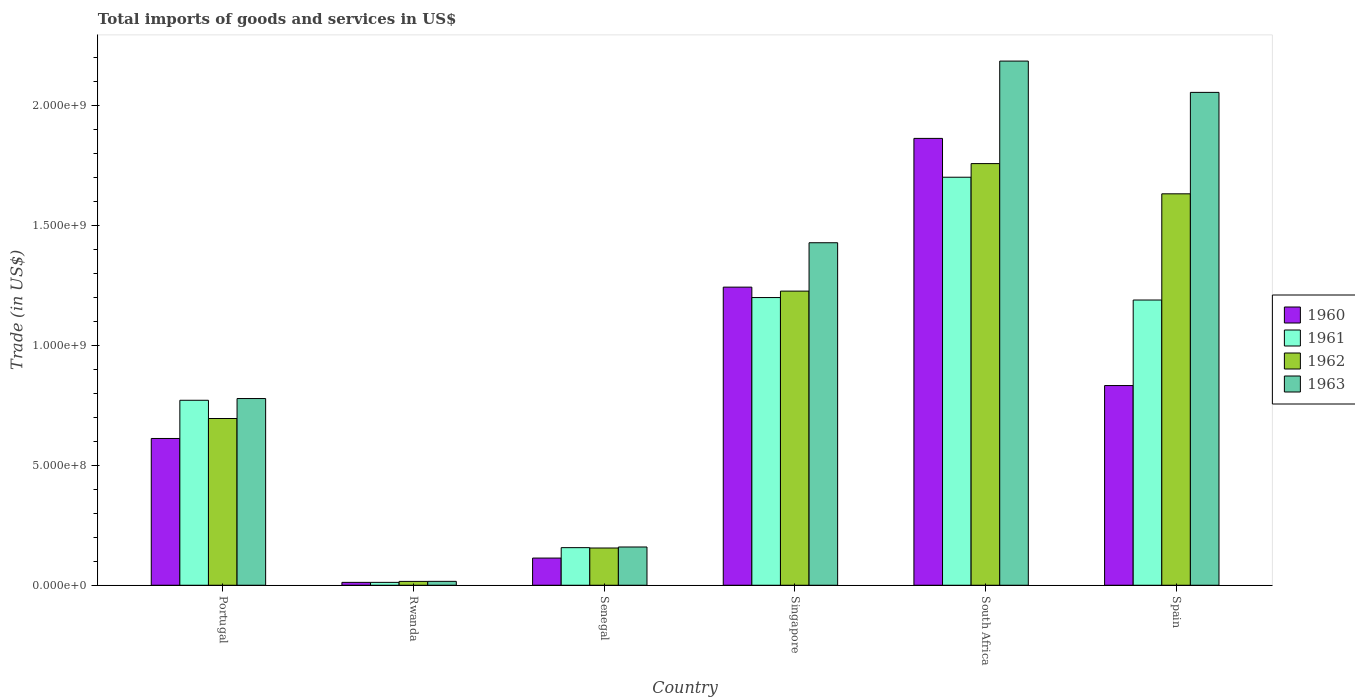How many groups of bars are there?
Keep it short and to the point. 6. Are the number of bars per tick equal to the number of legend labels?
Offer a very short reply. Yes. How many bars are there on the 5th tick from the right?
Provide a short and direct response. 4. What is the label of the 5th group of bars from the left?
Ensure brevity in your answer.  South Africa. What is the total imports of goods and services in 1963 in Singapore?
Offer a terse response. 1.43e+09. Across all countries, what is the maximum total imports of goods and services in 1961?
Make the answer very short. 1.70e+09. Across all countries, what is the minimum total imports of goods and services in 1963?
Provide a succinct answer. 1.62e+07. In which country was the total imports of goods and services in 1961 maximum?
Make the answer very short. South Africa. In which country was the total imports of goods and services in 1962 minimum?
Give a very brief answer. Rwanda. What is the total total imports of goods and services in 1963 in the graph?
Your response must be concise. 6.63e+09. What is the difference between the total imports of goods and services in 1960 in Rwanda and that in Spain?
Give a very brief answer. -8.21e+08. What is the difference between the total imports of goods and services in 1962 in Singapore and the total imports of goods and services in 1961 in Senegal?
Your answer should be compact. 1.07e+09. What is the average total imports of goods and services in 1960 per country?
Offer a terse response. 7.80e+08. What is the difference between the total imports of goods and services of/in 1960 and total imports of goods and services of/in 1963 in Spain?
Offer a very short reply. -1.22e+09. What is the ratio of the total imports of goods and services in 1961 in Portugal to that in South Africa?
Ensure brevity in your answer.  0.45. Is the total imports of goods and services in 1960 in Singapore less than that in South Africa?
Ensure brevity in your answer.  Yes. What is the difference between the highest and the second highest total imports of goods and services in 1962?
Provide a succinct answer. -5.32e+08. What is the difference between the highest and the lowest total imports of goods and services in 1961?
Keep it short and to the point. 1.69e+09. In how many countries, is the total imports of goods and services in 1963 greater than the average total imports of goods and services in 1963 taken over all countries?
Keep it short and to the point. 3. Is the sum of the total imports of goods and services in 1963 in Portugal and Singapore greater than the maximum total imports of goods and services in 1960 across all countries?
Your answer should be very brief. Yes. What does the 4th bar from the right in Portugal represents?
Your answer should be compact. 1960. Is it the case that in every country, the sum of the total imports of goods and services in 1963 and total imports of goods and services in 1961 is greater than the total imports of goods and services in 1960?
Your answer should be compact. Yes. How many bars are there?
Provide a short and direct response. 24. What is the difference between two consecutive major ticks on the Y-axis?
Ensure brevity in your answer.  5.00e+08. Are the values on the major ticks of Y-axis written in scientific E-notation?
Provide a succinct answer. Yes. Does the graph contain any zero values?
Provide a succinct answer. No. Does the graph contain grids?
Provide a succinct answer. No. How are the legend labels stacked?
Your answer should be compact. Vertical. What is the title of the graph?
Provide a succinct answer. Total imports of goods and services in US$. What is the label or title of the X-axis?
Offer a terse response. Country. What is the label or title of the Y-axis?
Make the answer very short. Trade (in US$). What is the Trade (in US$) in 1960 in Portugal?
Your answer should be compact. 6.12e+08. What is the Trade (in US$) in 1961 in Portugal?
Your answer should be compact. 7.72e+08. What is the Trade (in US$) of 1962 in Portugal?
Keep it short and to the point. 6.96e+08. What is the Trade (in US$) in 1963 in Portugal?
Provide a succinct answer. 7.79e+08. What is the Trade (in US$) in 1960 in Rwanda?
Provide a succinct answer. 1.20e+07. What is the Trade (in US$) of 1961 in Rwanda?
Offer a very short reply. 1.20e+07. What is the Trade (in US$) of 1962 in Rwanda?
Your answer should be very brief. 1.60e+07. What is the Trade (in US$) in 1963 in Rwanda?
Offer a very short reply. 1.62e+07. What is the Trade (in US$) of 1960 in Senegal?
Keep it short and to the point. 1.13e+08. What is the Trade (in US$) in 1961 in Senegal?
Your answer should be compact. 1.57e+08. What is the Trade (in US$) in 1962 in Senegal?
Provide a succinct answer. 1.55e+08. What is the Trade (in US$) in 1963 in Senegal?
Provide a short and direct response. 1.60e+08. What is the Trade (in US$) of 1960 in Singapore?
Your answer should be compact. 1.24e+09. What is the Trade (in US$) in 1961 in Singapore?
Your response must be concise. 1.20e+09. What is the Trade (in US$) of 1962 in Singapore?
Your answer should be compact. 1.23e+09. What is the Trade (in US$) in 1963 in Singapore?
Provide a succinct answer. 1.43e+09. What is the Trade (in US$) of 1960 in South Africa?
Keep it short and to the point. 1.86e+09. What is the Trade (in US$) in 1961 in South Africa?
Give a very brief answer. 1.70e+09. What is the Trade (in US$) of 1962 in South Africa?
Your answer should be compact. 1.76e+09. What is the Trade (in US$) of 1963 in South Africa?
Make the answer very short. 2.19e+09. What is the Trade (in US$) in 1960 in Spain?
Provide a short and direct response. 8.33e+08. What is the Trade (in US$) of 1961 in Spain?
Your response must be concise. 1.19e+09. What is the Trade (in US$) in 1962 in Spain?
Offer a terse response. 1.63e+09. What is the Trade (in US$) in 1963 in Spain?
Keep it short and to the point. 2.06e+09. Across all countries, what is the maximum Trade (in US$) of 1960?
Provide a short and direct response. 1.86e+09. Across all countries, what is the maximum Trade (in US$) in 1961?
Offer a terse response. 1.70e+09. Across all countries, what is the maximum Trade (in US$) of 1962?
Offer a terse response. 1.76e+09. Across all countries, what is the maximum Trade (in US$) of 1963?
Give a very brief answer. 2.19e+09. Across all countries, what is the minimum Trade (in US$) of 1960?
Provide a short and direct response. 1.20e+07. Across all countries, what is the minimum Trade (in US$) in 1961?
Offer a very short reply. 1.20e+07. Across all countries, what is the minimum Trade (in US$) in 1962?
Give a very brief answer. 1.60e+07. Across all countries, what is the minimum Trade (in US$) in 1963?
Make the answer very short. 1.62e+07. What is the total Trade (in US$) of 1960 in the graph?
Keep it short and to the point. 4.68e+09. What is the total Trade (in US$) in 1961 in the graph?
Offer a very short reply. 5.03e+09. What is the total Trade (in US$) of 1962 in the graph?
Provide a succinct answer. 5.49e+09. What is the total Trade (in US$) of 1963 in the graph?
Ensure brevity in your answer.  6.63e+09. What is the difference between the Trade (in US$) of 1960 in Portugal and that in Rwanda?
Give a very brief answer. 6.00e+08. What is the difference between the Trade (in US$) in 1961 in Portugal and that in Rwanda?
Your response must be concise. 7.60e+08. What is the difference between the Trade (in US$) in 1962 in Portugal and that in Rwanda?
Give a very brief answer. 6.80e+08. What is the difference between the Trade (in US$) of 1963 in Portugal and that in Rwanda?
Make the answer very short. 7.63e+08. What is the difference between the Trade (in US$) of 1960 in Portugal and that in Senegal?
Ensure brevity in your answer.  4.99e+08. What is the difference between the Trade (in US$) in 1961 in Portugal and that in Senegal?
Provide a succinct answer. 6.15e+08. What is the difference between the Trade (in US$) in 1962 in Portugal and that in Senegal?
Give a very brief answer. 5.40e+08. What is the difference between the Trade (in US$) of 1963 in Portugal and that in Senegal?
Ensure brevity in your answer.  6.19e+08. What is the difference between the Trade (in US$) in 1960 in Portugal and that in Singapore?
Make the answer very short. -6.31e+08. What is the difference between the Trade (in US$) in 1961 in Portugal and that in Singapore?
Offer a very short reply. -4.29e+08. What is the difference between the Trade (in US$) in 1962 in Portugal and that in Singapore?
Provide a short and direct response. -5.32e+08. What is the difference between the Trade (in US$) in 1963 in Portugal and that in Singapore?
Your response must be concise. -6.50e+08. What is the difference between the Trade (in US$) of 1960 in Portugal and that in South Africa?
Offer a very short reply. -1.25e+09. What is the difference between the Trade (in US$) in 1961 in Portugal and that in South Africa?
Provide a succinct answer. -9.31e+08. What is the difference between the Trade (in US$) in 1962 in Portugal and that in South Africa?
Offer a terse response. -1.06e+09. What is the difference between the Trade (in US$) in 1963 in Portugal and that in South Africa?
Make the answer very short. -1.41e+09. What is the difference between the Trade (in US$) of 1960 in Portugal and that in Spain?
Keep it short and to the point. -2.21e+08. What is the difference between the Trade (in US$) in 1961 in Portugal and that in Spain?
Make the answer very short. -4.18e+08. What is the difference between the Trade (in US$) in 1962 in Portugal and that in Spain?
Your answer should be very brief. -9.37e+08. What is the difference between the Trade (in US$) of 1963 in Portugal and that in Spain?
Ensure brevity in your answer.  -1.28e+09. What is the difference between the Trade (in US$) in 1960 in Rwanda and that in Senegal?
Ensure brevity in your answer.  -1.01e+08. What is the difference between the Trade (in US$) in 1961 in Rwanda and that in Senegal?
Offer a terse response. -1.45e+08. What is the difference between the Trade (in US$) in 1962 in Rwanda and that in Senegal?
Provide a short and direct response. -1.39e+08. What is the difference between the Trade (in US$) in 1963 in Rwanda and that in Senegal?
Give a very brief answer. -1.43e+08. What is the difference between the Trade (in US$) of 1960 in Rwanda and that in Singapore?
Your answer should be very brief. -1.23e+09. What is the difference between the Trade (in US$) of 1961 in Rwanda and that in Singapore?
Your answer should be very brief. -1.19e+09. What is the difference between the Trade (in US$) in 1962 in Rwanda and that in Singapore?
Your answer should be compact. -1.21e+09. What is the difference between the Trade (in US$) of 1963 in Rwanda and that in Singapore?
Provide a succinct answer. -1.41e+09. What is the difference between the Trade (in US$) of 1960 in Rwanda and that in South Africa?
Keep it short and to the point. -1.85e+09. What is the difference between the Trade (in US$) in 1961 in Rwanda and that in South Africa?
Provide a short and direct response. -1.69e+09. What is the difference between the Trade (in US$) in 1962 in Rwanda and that in South Africa?
Offer a very short reply. -1.74e+09. What is the difference between the Trade (in US$) in 1963 in Rwanda and that in South Africa?
Provide a succinct answer. -2.17e+09. What is the difference between the Trade (in US$) of 1960 in Rwanda and that in Spain?
Your answer should be very brief. -8.21e+08. What is the difference between the Trade (in US$) of 1961 in Rwanda and that in Spain?
Your answer should be compact. -1.18e+09. What is the difference between the Trade (in US$) of 1962 in Rwanda and that in Spain?
Provide a succinct answer. -1.62e+09. What is the difference between the Trade (in US$) of 1963 in Rwanda and that in Spain?
Ensure brevity in your answer.  -2.04e+09. What is the difference between the Trade (in US$) of 1960 in Senegal and that in Singapore?
Give a very brief answer. -1.13e+09. What is the difference between the Trade (in US$) in 1961 in Senegal and that in Singapore?
Make the answer very short. -1.04e+09. What is the difference between the Trade (in US$) of 1962 in Senegal and that in Singapore?
Your answer should be very brief. -1.07e+09. What is the difference between the Trade (in US$) in 1963 in Senegal and that in Singapore?
Your answer should be compact. -1.27e+09. What is the difference between the Trade (in US$) in 1960 in Senegal and that in South Africa?
Offer a terse response. -1.75e+09. What is the difference between the Trade (in US$) of 1961 in Senegal and that in South Africa?
Your answer should be very brief. -1.55e+09. What is the difference between the Trade (in US$) of 1962 in Senegal and that in South Africa?
Provide a short and direct response. -1.60e+09. What is the difference between the Trade (in US$) in 1963 in Senegal and that in South Africa?
Make the answer very short. -2.03e+09. What is the difference between the Trade (in US$) of 1960 in Senegal and that in Spain?
Your response must be concise. -7.20e+08. What is the difference between the Trade (in US$) of 1961 in Senegal and that in Spain?
Provide a short and direct response. -1.03e+09. What is the difference between the Trade (in US$) in 1962 in Senegal and that in Spain?
Keep it short and to the point. -1.48e+09. What is the difference between the Trade (in US$) of 1963 in Senegal and that in Spain?
Your answer should be compact. -1.90e+09. What is the difference between the Trade (in US$) in 1960 in Singapore and that in South Africa?
Ensure brevity in your answer.  -6.21e+08. What is the difference between the Trade (in US$) of 1961 in Singapore and that in South Africa?
Make the answer very short. -5.02e+08. What is the difference between the Trade (in US$) of 1962 in Singapore and that in South Africa?
Your response must be concise. -5.32e+08. What is the difference between the Trade (in US$) of 1963 in Singapore and that in South Africa?
Provide a short and direct response. -7.58e+08. What is the difference between the Trade (in US$) in 1960 in Singapore and that in Spain?
Give a very brief answer. 4.11e+08. What is the difference between the Trade (in US$) of 1961 in Singapore and that in Spain?
Give a very brief answer. 1.03e+07. What is the difference between the Trade (in US$) of 1962 in Singapore and that in Spain?
Keep it short and to the point. -4.06e+08. What is the difference between the Trade (in US$) in 1963 in Singapore and that in Spain?
Provide a succinct answer. -6.27e+08. What is the difference between the Trade (in US$) in 1960 in South Africa and that in Spain?
Provide a succinct answer. 1.03e+09. What is the difference between the Trade (in US$) in 1961 in South Africa and that in Spain?
Give a very brief answer. 5.12e+08. What is the difference between the Trade (in US$) of 1962 in South Africa and that in Spain?
Keep it short and to the point. 1.26e+08. What is the difference between the Trade (in US$) in 1963 in South Africa and that in Spain?
Give a very brief answer. 1.31e+08. What is the difference between the Trade (in US$) of 1960 in Portugal and the Trade (in US$) of 1961 in Rwanda?
Your response must be concise. 6.00e+08. What is the difference between the Trade (in US$) of 1960 in Portugal and the Trade (in US$) of 1962 in Rwanda?
Give a very brief answer. 5.96e+08. What is the difference between the Trade (in US$) in 1960 in Portugal and the Trade (in US$) in 1963 in Rwanda?
Give a very brief answer. 5.96e+08. What is the difference between the Trade (in US$) in 1961 in Portugal and the Trade (in US$) in 1962 in Rwanda?
Your answer should be very brief. 7.56e+08. What is the difference between the Trade (in US$) in 1961 in Portugal and the Trade (in US$) in 1963 in Rwanda?
Your answer should be very brief. 7.55e+08. What is the difference between the Trade (in US$) of 1962 in Portugal and the Trade (in US$) of 1963 in Rwanda?
Make the answer very short. 6.79e+08. What is the difference between the Trade (in US$) of 1960 in Portugal and the Trade (in US$) of 1961 in Senegal?
Offer a very short reply. 4.55e+08. What is the difference between the Trade (in US$) of 1960 in Portugal and the Trade (in US$) of 1962 in Senegal?
Offer a very short reply. 4.57e+08. What is the difference between the Trade (in US$) in 1960 in Portugal and the Trade (in US$) in 1963 in Senegal?
Your response must be concise. 4.53e+08. What is the difference between the Trade (in US$) of 1961 in Portugal and the Trade (in US$) of 1962 in Senegal?
Your response must be concise. 6.16e+08. What is the difference between the Trade (in US$) of 1961 in Portugal and the Trade (in US$) of 1963 in Senegal?
Give a very brief answer. 6.12e+08. What is the difference between the Trade (in US$) of 1962 in Portugal and the Trade (in US$) of 1963 in Senegal?
Your response must be concise. 5.36e+08. What is the difference between the Trade (in US$) of 1960 in Portugal and the Trade (in US$) of 1961 in Singapore?
Make the answer very short. -5.88e+08. What is the difference between the Trade (in US$) in 1960 in Portugal and the Trade (in US$) in 1962 in Singapore?
Provide a succinct answer. -6.15e+08. What is the difference between the Trade (in US$) of 1960 in Portugal and the Trade (in US$) of 1963 in Singapore?
Provide a succinct answer. -8.17e+08. What is the difference between the Trade (in US$) of 1961 in Portugal and the Trade (in US$) of 1962 in Singapore?
Offer a very short reply. -4.55e+08. What is the difference between the Trade (in US$) in 1961 in Portugal and the Trade (in US$) in 1963 in Singapore?
Your answer should be very brief. -6.57e+08. What is the difference between the Trade (in US$) in 1962 in Portugal and the Trade (in US$) in 1963 in Singapore?
Your answer should be compact. -7.33e+08. What is the difference between the Trade (in US$) of 1960 in Portugal and the Trade (in US$) of 1961 in South Africa?
Offer a terse response. -1.09e+09. What is the difference between the Trade (in US$) in 1960 in Portugal and the Trade (in US$) in 1962 in South Africa?
Offer a terse response. -1.15e+09. What is the difference between the Trade (in US$) in 1960 in Portugal and the Trade (in US$) in 1963 in South Africa?
Your answer should be compact. -1.57e+09. What is the difference between the Trade (in US$) of 1961 in Portugal and the Trade (in US$) of 1962 in South Africa?
Make the answer very short. -9.87e+08. What is the difference between the Trade (in US$) of 1961 in Portugal and the Trade (in US$) of 1963 in South Africa?
Your answer should be very brief. -1.42e+09. What is the difference between the Trade (in US$) in 1962 in Portugal and the Trade (in US$) in 1963 in South Africa?
Give a very brief answer. -1.49e+09. What is the difference between the Trade (in US$) in 1960 in Portugal and the Trade (in US$) in 1961 in Spain?
Your answer should be compact. -5.78e+08. What is the difference between the Trade (in US$) in 1960 in Portugal and the Trade (in US$) in 1962 in Spain?
Keep it short and to the point. -1.02e+09. What is the difference between the Trade (in US$) in 1960 in Portugal and the Trade (in US$) in 1963 in Spain?
Keep it short and to the point. -1.44e+09. What is the difference between the Trade (in US$) of 1961 in Portugal and the Trade (in US$) of 1962 in Spain?
Provide a succinct answer. -8.61e+08. What is the difference between the Trade (in US$) in 1961 in Portugal and the Trade (in US$) in 1963 in Spain?
Provide a succinct answer. -1.28e+09. What is the difference between the Trade (in US$) of 1962 in Portugal and the Trade (in US$) of 1963 in Spain?
Give a very brief answer. -1.36e+09. What is the difference between the Trade (in US$) of 1960 in Rwanda and the Trade (in US$) of 1961 in Senegal?
Offer a very short reply. -1.45e+08. What is the difference between the Trade (in US$) of 1960 in Rwanda and the Trade (in US$) of 1962 in Senegal?
Your answer should be compact. -1.43e+08. What is the difference between the Trade (in US$) of 1960 in Rwanda and the Trade (in US$) of 1963 in Senegal?
Provide a succinct answer. -1.48e+08. What is the difference between the Trade (in US$) in 1961 in Rwanda and the Trade (in US$) in 1962 in Senegal?
Provide a succinct answer. -1.43e+08. What is the difference between the Trade (in US$) of 1961 in Rwanda and the Trade (in US$) of 1963 in Senegal?
Give a very brief answer. -1.48e+08. What is the difference between the Trade (in US$) of 1962 in Rwanda and the Trade (in US$) of 1963 in Senegal?
Your answer should be compact. -1.44e+08. What is the difference between the Trade (in US$) of 1960 in Rwanda and the Trade (in US$) of 1961 in Singapore?
Provide a short and direct response. -1.19e+09. What is the difference between the Trade (in US$) of 1960 in Rwanda and the Trade (in US$) of 1962 in Singapore?
Offer a terse response. -1.22e+09. What is the difference between the Trade (in US$) in 1960 in Rwanda and the Trade (in US$) in 1963 in Singapore?
Offer a very short reply. -1.42e+09. What is the difference between the Trade (in US$) of 1961 in Rwanda and the Trade (in US$) of 1962 in Singapore?
Ensure brevity in your answer.  -1.22e+09. What is the difference between the Trade (in US$) of 1961 in Rwanda and the Trade (in US$) of 1963 in Singapore?
Your answer should be compact. -1.42e+09. What is the difference between the Trade (in US$) in 1962 in Rwanda and the Trade (in US$) in 1963 in Singapore?
Offer a terse response. -1.41e+09. What is the difference between the Trade (in US$) of 1960 in Rwanda and the Trade (in US$) of 1961 in South Africa?
Make the answer very short. -1.69e+09. What is the difference between the Trade (in US$) of 1960 in Rwanda and the Trade (in US$) of 1962 in South Africa?
Offer a very short reply. -1.75e+09. What is the difference between the Trade (in US$) in 1960 in Rwanda and the Trade (in US$) in 1963 in South Africa?
Keep it short and to the point. -2.17e+09. What is the difference between the Trade (in US$) of 1961 in Rwanda and the Trade (in US$) of 1962 in South Africa?
Offer a very short reply. -1.75e+09. What is the difference between the Trade (in US$) of 1961 in Rwanda and the Trade (in US$) of 1963 in South Africa?
Offer a very short reply. -2.17e+09. What is the difference between the Trade (in US$) of 1962 in Rwanda and the Trade (in US$) of 1963 in South Africa?
Give a very brief answer. -2.17e+09. What is the difference between the Trade (in US$) of 1960 in Rwanda and the Trade (in US$) of 1961 in Spain?
Your answer should be very brief. -1.18e+09. What is the difference between the Trade (in US$) in 1960 in Rwanda and the Trade (in US$) in 1962 in Spain?
Offer a terse response. -1.62e+09. What is the difference between the Trade (in US$) in 1960 in Rwanda and the Trade (in US$) in 1963 in Spain?
Your response must be concise. -2.04e+09. What is the difference between the Trade (in US$) in 1961 in Rwanda and the Trade (in US$) in 1962 in Spain?
Offer a very short reply. -1.62e+09. What is the difference between the Trade (in US$) in 1961 in Rwanda and the Trade (in US$) in 1963 in Spain?
Your answer should be compact. -2.04e+09. What is the difference between the Trade (in US$) of 1962 in Rwanda and the Trade (in US$) of 1963 in Spain?
Offer a very short reply. -2.04e+09. What is the difference between the Trade (in US$) of 1960 in Senegal and the Trade (in US$) of 1961 in Singapore?
Provide a short and direct response. -1.09e+09. What is the difference between the Trade (in US$) in 1960 in Senegal and the Trade (in US$) in 1962 in Singapore?
Provide a succinct answer. -1.11e+09. What is the difference between the Trade (in US$) in 1960 in Senegal and the Trade (in US$) in 1963 in Singapore?
Provide a succinct answer. -1.32e+09. What is the difference between the Trade (in US$) of 1961 in Senegal and the Trade (in US$) of 1962 in Singapore?
Make the answer very short. -1.07e+09. What is the difference between the Trade (in US$) in 1961 in Senegal and the Trade (in US$) in 1963 in Singapore?
Offer a very short reply. -1.27e+09. What is the difference between the Trade (in US$) in 1962 in Senegal and the Trade (in US$) in 1963 in Singapore?
Offer a terse response. -1.27e+09. What is the difference between the Trade (in US$) of 1960 in Senegal and the Trade (in US$) of 1961 in South Africa?
Give a very brief answer. -1.59e+09. What is the difference between the Trade (in US$) of 1960 in Senegal and the Trade (in US$) of 1962 in South Africa?
Ensure brevity in your answer.  -1.65e+09. What is the difference between the Trade (in US$) of 1960 in Senegal and the Trade (in US$) of 1963 in South Africa?
Ensure brevity in your answer.  -2.07e+09. What is the difference between the Trade (in US$) of 1961 in Senegal and the Trade (in US$) of 1962 in South Africa?
Provide a short and direct response. -1.60e+09. What is the difference between the Trade (in US$) of 1961 in Senegal and the Trade (in US$) of 1963 in South Africa?
Ensure brevity in your answer.  -2.03e+09. What is the difference between the Trade (in US$) in 1962 in Senegal and the Trade (in US$) in 1963 in South Africa?
Keep it short and to the point. -2.03e+09. What is the difference between the Trade (in US$) in 1960 in Senegal and the Trade (in US$) in 1961 in Spain?
Provide a short and direct response. -1.08e+09. What is the difference between the Trade (in US$) in 1960 in Senegal and the Trade (in US$) in 1962 in Spain?
Make the answer very short. -1.52e+09. What is the difference between the Trade (in US$) in 1960 in Senegal and the Trade (in US$) in 1963 in Spain?
Offer a terse response. -1.94e+09. What is the difference between the Trade (in US$) of 1961 in Senegal and the Trade (in US$) of 1962 in Spain?
Provide a short and direct response. -1.48e+09. What is the difference between the Trade (in US$) of 1961 in Senegal and the Trade (in US$) of 1963 in Spain?
Offer a terse response. -1.90e+09. What is the difference between the Trade (in US$) in 1962 in Senegal and the Trade (in US$) in 1963 in Spain?
Provide a succinct answer. -1.90e+09. What is the difference between the Trade (in US$) of 1960 in Singapore and the Trade (in US$) of 1961 in South Africa?
Your answer should be compact. -4.59e+08. What is the difference between the Trade (in US$) in 1960 in Singapore and the Trade (in US$) in 1962 in South Africa?
Provide a short and direct response. -5.15e+08. What is the difference between the Trade (in US$) of 1960 in Singapore and the Trade (in US$) of 1963 in South Africa?
Provide a short and direct response. -9.43e+08. What is the difference between the Trade (in US$) of 1961 in Singapore and the Trade (in US$) of 1962 in South Africa?
Offer a very short reply. -5.59e+08. What is the difference between the Trade (in US$) in 1961 in Singapore and the Trade (in US$) in 1963 in South Africa?
Provide a short and direct response. -9.87e+08. What is the difference between the Trade (in US$) of 1962 in Singapore and the Trade (in US$) of 1963 in South Africa?
Offer a very short reply. -9.60e+08. What is the difference between the Trade (in US$) of 1960 in Singapore and the Trade (in US$) of 1961 in Spain?
Provide a short and direct response. 5.38e+07. What is the difference between the Trade (in US$) in 1960 in Singapore and the Trade (in US$) in 1962 in Spain?
Ensure brevity in your answer.  -3.89e+08. What is the difference between the Trade (in US$) of 1960 in Singapore and the Trade (in US$) of 1963 in Spain?
Your answer should be compact. -8.13e+08. What is the difference between the Trade (in US$) in 1961 in Singapore and the Trade (in US$) in 1962 in Spain?
Keep it short and to the point. -4.33e+08. What is the difference between the Trade (in US$) of 1961 in Singapore and the Trade (in US$) of 1963 in Spain?
Provide a succinct answer. -8.56e+08. What is the difference between the Trade (in US$) of 1962 in Singapore and the Trade (in US$) of 1963 in Spain?
Provide a succinct answer. -8.29e+08. What is the difference between the Trade (in US$) of 1960 in South Africa and the Trade (in US$) of 1961 in Spain?
Make the answer very short. 6.74e+08. What is the difference between the Trade (in US$) in 1960 in South Africa and the Trade (in US$) in 1962 in Spain?
Your answer should be compact. 2.31e+08. What is the difference between the Trade (in US$) of 1960 in South Africa and the Trade (in US$) of 1963 in Spain?
Provide a succinct answer. -1.92e+08. What is the difference between the Trade (in US$) of 1961 in South Africa and the Trade (in US$) of 1962 in Spain?
Keep it short and to the point. 6.92e+07. What is the difference between the Trade (in US$) in 1961 in South Africa and the Trade (in US$) in 1963 in Spain?
Give a very brief answer. -3.54e+08. What is the difference between the Trade (in US$) in 1962 in South Africa and the Trade (in US$) in 1963 in Spain?
Make the answer very short. -2.97e+08. What is the average Trade (in US$) in 1960 per country?
Your answer should be compact. 7.80e+08. What is the average Trade (in US$) of 1961 per country?
Ensure brevity in your answer.  8.39e+08. What is the average Trade (in US$) of 1962 per country?
Keep it short and to the point. 9.14e+08. What is the average Trade (in US$) in 1963 per country?
Give a very brief answer. 1.10e+09. What is the difference between the Trade (in US$) of 1960 and Trade (in US$) of 1961 in Portugal?
Provide a short and direct response. -1.59e+08. What is the difference between the Trade (in US$) in 1960 and Trade (in US$) in 1962 in Portugal?
Make the answer very short. -8.33e+07. What is the difference between the Trade (in US$) in 1960 and Trade (in US$) in 1963 in Portugal?
Your response must be concise. -1.67e+08. What is the difference between the Trade (in US$) of 1961 and Trade (in US$) of 1962 in Portugal?
Give a very brief answer. 7.61e+07. What is the difference between the Trade (in US$) of 1961 and Trade (in US$) of 1963 in Portugal?
Make the answer very short. -7.25e+06. What is the difference between the Trade (in US$) of 1962 and Trade (in US$) of 1963 in Portugal?
Offer a terse response. -8.33e+07. What is the difference between the Trade (in US$) in 1960 and Trade (in US$) in 1961 in Rwanda?
Provide a short and direct response. 0. What is the difference between the Trade (in US$) in 1960 and Trade (in US$) in 1962 in Rwanda?
Provide a succinct answer. -4.00e+06. What is the difference between the Trade (in US$) in 1960 and Trade (in US$) in 1963 in Rwanda?
Your answer should be very brief. -4.20e+06. What is the difference between the Trade (in US$) in 1961 and Trade (in US$) in 1962 in Rwanda?
Provide a short and direct response. -4.00e+06. What is the difference between the Trade (in US$) of 1961 and Trade (in US$) of 1963 in Rwanda?
Your answer should be compact. -4.20e+06. What is the difference between the Trade (in US$) in 1962 and Trade (in US$) in 1963 in Rwanda?
Your answer should be very brief. -2.00e+05. What is the difference between the Trade (in US$) of 1960 and Trade (in US$) of 1961 in Senegal?
Your response must be concise. -4.35e+07. What is the difference between the Trade (in US$) of 1960 and Trade (in US$) of 1962 in Senegal?
Make the answer very short. -4.20e+07. What is the difference between the Trade (in US$) in 1960 and Trade (in US$) in 1963 in Senegal?
Offer a terse response. -4.62e+07. What is the difference between the Trade (in US$) in 1961 and Trade (in US$) in 1962 in Senegal?
Provide a succinct answer. 1.49e+06. What is the difference between the Trade (in US$) in 1961 and Trade (in US$) in 1963 in Senegal?
Provide a succinct answer. -2.79e+06. What is the difference between the Trade (in US$) of 1962 and Trade (in US$) of 1963 in Senegal?
Keep it short and to the point. -4.29e+06. What is the difference between the Trade (in US$) in 1960 and Trade (in US$) in 1961 in Singapore?
Your answer should be very brief. 4.34e+07. What is the difference between the Trade (in US$) in 1960 and Trade (in US$) in 1962 in Singapore?
Your response must be concise. 1.66e+07. What is the difference between the Trade (in US$) in 1960 and Trade (in US$) in 1963 in Singapore?
Your response must be concise. -1.85e+08. What is the difference between the Trade (in US$) of 1961 and Trade (in US$) of 1962 in Singapore?
Provide a succinct answer. -2.69e+07. What is the difference between the Trade (in US$) of 1961 and Trade (in US$) of 1963 in Singapore?
Ensure brevity in your answer.  -2.29e+08. What is the difference between the Trade (in US$) of 1962 and Trade (in US$) of 1963 in Singapore?
Provide a succinct answer. -2.02e+08. What is the difference between the Trade (in US$) of 1960 and Trade (in US$) of 1961 in South Africa?
Your response must be concise. 1.62e+08. What is the difference between the Trade (in US$) in 1960 and Trade (in US$) in 1962 in South Africa?
Your answer should be compact. 1.05e+08. What is the difference between the Trade (in US$) in 1960 and Trade (in US$) in 1963 in South Africa?
Ensure brevity in your answer.  -3.23e+08. What is the difference between the Trade (in US$) of 1961 and Trade (in US$) of 1962 in South Africa?
Offer a very short reply. -5.68e+07. What is the difference between the Trade (in US$) of 1961 and Trade (in US$) of 1963 in South Africa?
Provide a short and direct response. -4.85e+08. What is the difference between the Trade (in US$) in 1962 and Trade (in US$) in 1963 in South Africa?
Give a very brief answer. -4.28e+08. What is the difference between the Trade (in US$) of 1960 and Trade (in US$) of 1961 in Spain?
Your response must be concise. -3.57e+08. What is the difference between the Trade (in US$) in 1960 and Trade (in US$) in 1962 in Spain?
Offer a terse response. -8.00e+08. What is the difference between the Trade (in US$) in 1960 and Trade (in US$) in 1963 in Spain?
Offer a terse response. -1.22e+09. What is the difference between the Trade (in US$) in 1961 and Trade (in US$) in 1962 in Spain?
Your answer should be very brief. -4.43e+08. What is the difference between the Trade (in US$) of 1961 and Trade (in US$) of 1963 in Spain?
Ensure brevity in your answer.  -8.66e+08. What is the difference between the Trade (in US$) in 1962 and Trade (in US$) in 1963 in Spain?
Offer a terse response. -4.23e+08. What is the ratio of the Trade (in US$) in 1960 in Portugal to that in Rwanda?
Ensure brevity in your answer.  51.02. What is the ratio of the Trade (in US$) of 1961 in Portugal to that in Rwanda?
Your response must be concise. 64.31. What is the ratio of the Trade (in US$) in 1962 in Portugal to that in Rwanda?
Keep it short and to the point. 43.48. What is the ratio of the Trade (in US$) of 1963 in Portugal to that in Rwanda?
Offer a terse response. 48.08. What is the ratio of the Trade (in US$) in 1960 in Portugal to that in Senegal?
Offer a terse response. 5.4. What is the ratio of the Trade (in US$) of 1961 in Portugal to that in Senegal?
Keep it short and to the point. 4.92. What is the ratio of the Trade (in US$) in 1962 in Portugal to that in Senegal?
Ensure brevity in your answer.  4.48. What is the ratio of the Trade (in US$) of 1963 in Portugal to that in Senegal?
Your response must be concise. 4.88. What is the ratio of the Trade (in US$) of 1960 in Portugal to that in Singapore?
Your answer should be very brief. 0.49. What is the ratio of the Trade (in US$) of 1961 in Portugal to that in Singapore?
Your answer should be very brief. 0.64. What is the ratio of the Trade (in US$) of 1962 in Portugal to that in Singapore?
Offer a very short reply. 0.57. What is the ratio of the Trade (in US$) of 1963 in Portugal to that in Singapore?
Keep it short and to the point. 0.55. What is the ratio of the Trade (in US$) in 1960 in Portugal to that in South Africa?
Ensure brevity in your answer.  0.33. What is the ratio of the Trade (in US$) of 1961 in Portugal to that in South Africa?
Offer a very short reply. 0.45. What is the ratio of the Trade (in US$) of 1962 in Portugal to that in South Africa?
Give a very brief answer. 0.4. What is the ratio of the Trade (in US$) of 1963 in Portugal to that in South Africa?
Ensure brevity in your answer.  0.36. What is the ratio of the Trade (in US$) of 1960 in Portugal to that in Spain?
Provide a succinct answer. 0.73. What is the ratio of the Trade (in US$) of 1961 in Portugal to that in Spain?
Ensure brevity in your answer.  0.65. What is the ratio of the Trade (in US$) of 1962 in Portugal to that in Spain?
Offer a very short reply. 0.43. What is the ratio of the Trade (in US$) of 1963 in Portugal to that in Spain?
Your answer should be very brief. 0.38. What is the ratio of the Trade (in US$) of 1960 in Rwanda to that in Senegal?
Give a very brief answer. 0.11. What is the ratio of the Trade (in US$) of 1961 in Rwanda to that in Senegal?
Make the answer very short. 0.08. What is the ratio of the Trade (in US$) of 1962 in Rwanda to that in Senegal?
Keep it short and to the point. 0.1. What is the ratio of the Trade (in US$) of 1963 in Rwanda to that in Senegal?
Make the answer very short. 0.1. What is the ratio of the Trade (in US$) of 1960 in Rwanda to that in Singapore?
Your answer should be very brief. 0.01. What is the ratio of the Trade (in US$) of 1962 in Rwanda to that in Singapore?
Ensure brevity in your answer.  0.01. What is the ratio of the Trade (in US$) in 1963 in Rwanda to that in Singapore?
Give a very brief answer. 0.01. What is the ratio of the Trade (in US$) of 1960 in Rwanda to that in South Africa?
Provide a short and direct response. 0.01. What is the ratio of the Trade (in US$) of 1961 in Rwanda to that in South Africa?
Give a very brief answer. 0.01. What is the ratio of the Trade (in US$) in 1962 in Rwanda to that in South Africa?
Keep it short and to the point. 0.01. What is the ratio of the Trade (in US$) in 1963 in Rwanda to that in South Africa?
Your response must be concise. 0.01. What is the ratio of the Trade (in US$) in 1960 in Rwanda to that in Spain?
Provide a short and direct response. 0.01. What is the ratio of the Trade (in US$) in 1961 in Rwanda to that in Spain?
Offer a terse response. 0.01. What is the ratio of the Trade (in US$) of 1962 in Rwanda to that in Spain?
Make the answer very short. 0.01. What is the ratio of the Trade (in US$) in 1963 in Rwanda to that in Spain?
Your response must be concise. 0.01. What is the ratio of the Trade (in US$) in 1960 in Senegal to that in Singapore?
Offer a very short reply. 0.09. What is the ratio of the Trade (in US$) in 1961 in Senegal to that in Singapore?
Your answer should be compact. 0.13. What is the ratio of the Trade (in US$) in 1962 in Senegal to that in Singapore?
Offer a terse response. 0.13. What is the ratio of the Trade (in US$) in 1963 in Senegal to that in Singapore?
Your response must be concise. 0.11. What is the ratio of the Trade (in US$) of 1960 in Senegal to that in South Africa?
Give a very brief answer. 0.06. What is the ratio of the Trade (in US$) of 1961 in Senegal to that in South Africa?
Give a very brief answer. 0.09. What is the ratio of the Trade (in US$) in 1962 in Senegal to that in South Africa?
Your response must be concise. 0.09. What is the ratio of the Trade (in US$) of 1963 in Senegal to that in South Africa?
Offer a terse response. 0.07. What is the ratio of the Trade (in US$) in 1960 in Senegal to that in Spain?
Offer a very short reply. 0.14. What is the ratio of the Trade (in US$) of 1961 in Senegal to that in Spain?
Provide a succinct answer. 0.13. What is the ratio of the Trade (in US$) of 1962 in Senegal to that in Spain?
Provide a succinct answer. 0.1. What is the ratio of the Trade (in US$) in 1963 in Senegal to that in Spain?
Provide a short and direct response. 0.08. What is the ratio of the Trade (in US$) in 1960 in Singapore to that in South Africa?
Your response must be concise. 0.67. What is the ratio of the Trade (in US$) in 1961 in Singapore to that in South Africa?
Your response must be concise. 0.71. What is the ratio of the Trade (in US$) of 1962 in Singapore to that in South Africa?
Provide a succinct answer. 0.7. What is the ratio of the Trade (in US$) in 1963 in Singapore to that in South Africa?
Keep it short and to the point. 0.65. What is the ratio of the Trade (in US$) in 1960 in Singapore to that in Spain?
Ensure brevity in your answer.  1.49. What is the ratio of the Trade (in US$) of 1961 in Singapore to that in Spain?
Provide a short and direct response. 1.01. What is the ratio of the Trade (in US$) of 1962 in Singapore to that in Spain?
Give a very brief answer. 0.75. What is the ratio of the Trade (in US$) in 1963 in Singapore to that in Spain?
Provide a short and direct response. 0.69. What is the ratio of the Trade (in US$) in 1960 in South Africa to that in Spain?
Your answer should be very brief. 2.24. What is the ratio of the Trade (in US$) of 1961 in South Africa to that in Spain?
Make the answer very short. 1.43. What is the ratio of the Trade (in US$) in 1962 in South Africa to that in Spain?
Offer a terse response. 1.08. What is the ratio of the Trade (in US$) in 1963 in South Africa to that in Spain?
Offer a very short reply. 1.06. What is the difference between the highest and the second highest Trade (in US$) in 1960?
Provide a short and direct response. 6.21e+08. What is the difference between the highest and the second highest Trade (in US$) in 1961?
Give a very brief answer. 5.02e+08. What is the difference between the highest and the second highest Trade (in US$) of 1962?
Your response must be concise. 1.26e+08. What is the difference between the highest and the second highest Trade (in US$) in 1963?
Give a very brief answer. 1.31e+08. What is the difference between the highest and the lowest Trade (in US$) of 1960?
Keep it short and to the point. 1.85e+09. What is the difference between the highest and the lowest Trade (in US$) in 1961?
Provide a succinct answer. 1.69e+09. What is the difference between the highest and the lowest Trade (in US$) in 1962?
Your response must be concise. 1.74e+09. What is the difference between the highest and the lowest Trade (in US$) in 1963?
Your answer should be very brief. 2.17e+09. 